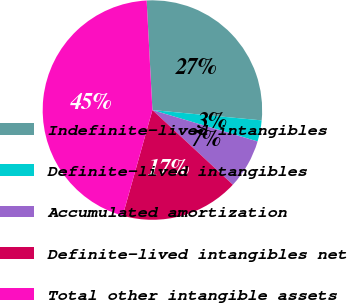Convert chart. <chart><loc_0><loc_0><loc_500><loc_500><pie_chart><fcel>Indefinite-lived intangibles<fcel>Definite-lived intangibles<fcel>Accumulated amortization<fcel>Definite-lived intangibles net<fcel>Total other intangible assets<nl><fcel>27.34%<fcel>3.12%<fcel>7.29%<fcel>17.46%<fcel>44.8%<nl></chart> 